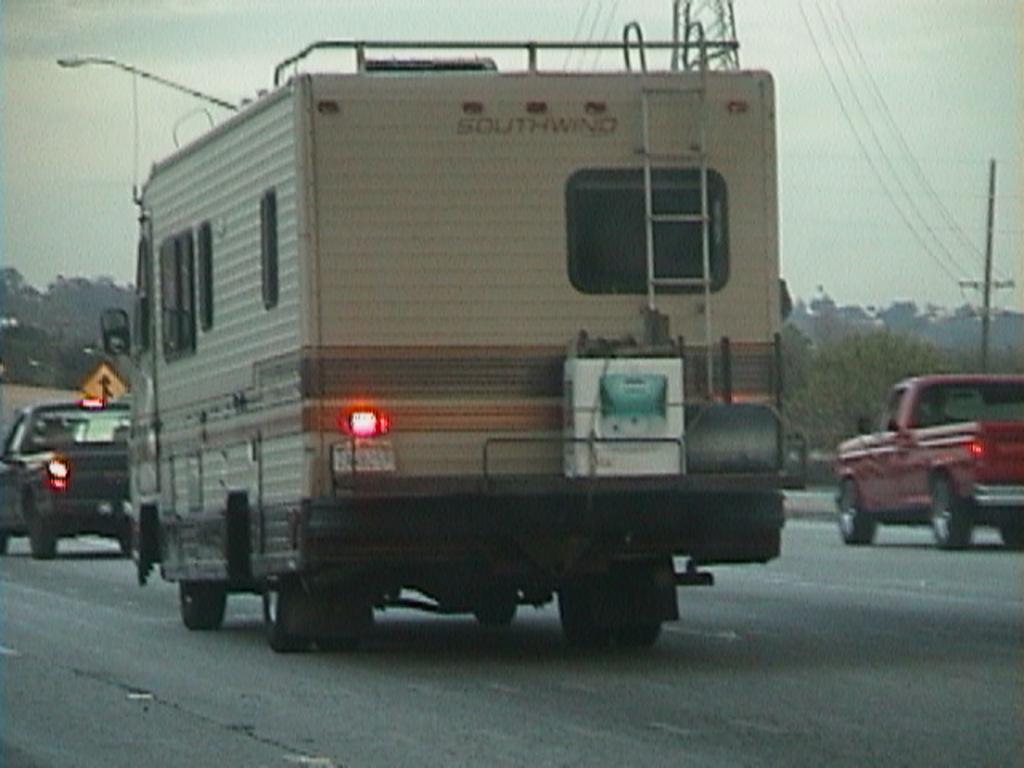How would you summarize this image in a sentence or two? There are vehicles on the road. The lights are on. There are trees, sign board, electric poles and wires at the back. 